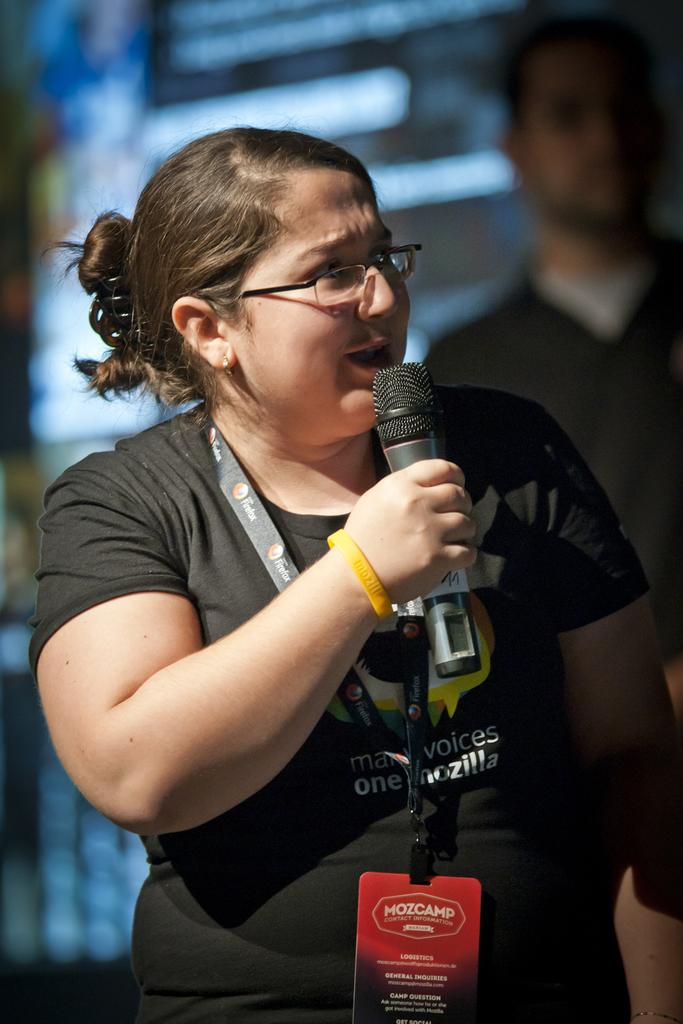Who is the main subject in the image? There is a woman in the image. What is the woman holding in her hand? The woman is holding a microphone in her hand. Can you describe the woman's appearance? The woman is wearing spectacles. Who else is present in the image? There is a man in the image. How is the man positioned in relation to the woman? The man is behind the woman. What type of silk fabric is draped over the appliance in the image? There is no silk fabric or appliance present in the image. What subject is the woman teaching in the image? The image does not depict the woman teaching a subject; she is holding a microphone, but the context is not clear. 